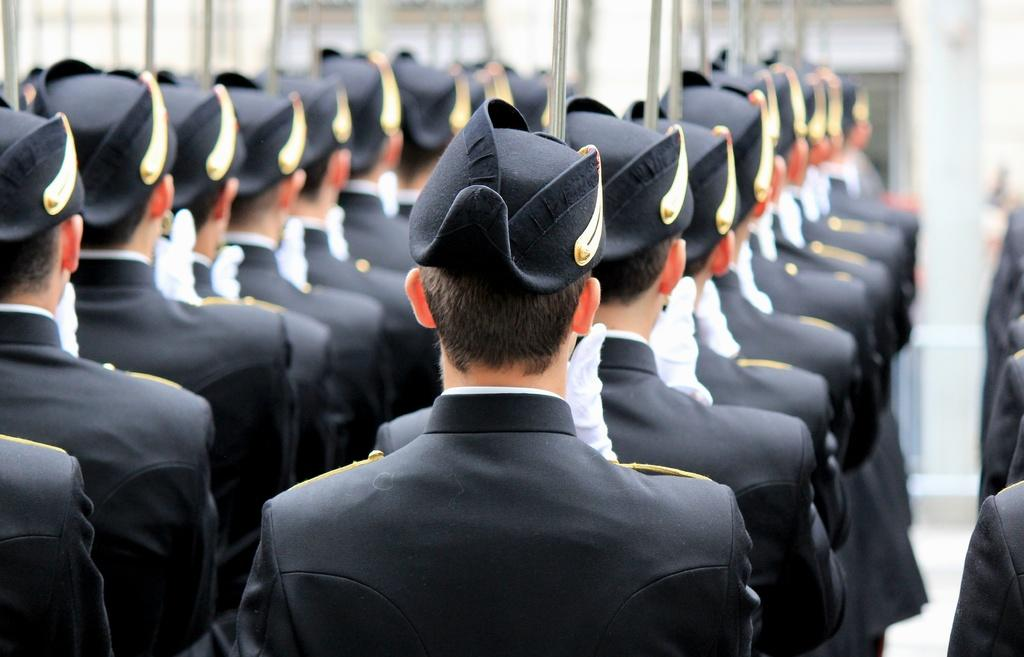What are the people in the image doing? The people in the image are standing in series. What are the people wearing? The people are wearing the same uniform. What can be seen in the background of the image? There appears to be a pillar and windows visible in the background of the image. What type of cream is being served on the pillar in the image? There is no cream or any food item present on the pillar in the image. How many clocks are visible in the image? There are no clocks visible in the image. 